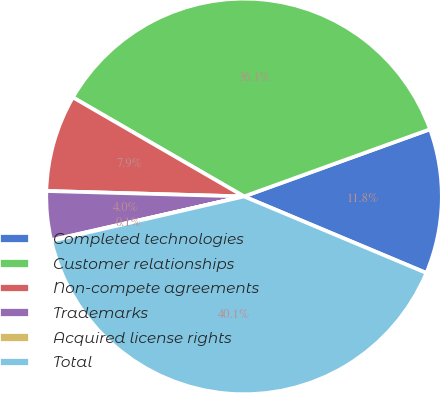Convert chart. <chart><loc_0><loc_0><loc_500><loc_500><pie_chart><fcel>Completed technologies<fcel>Customer relationships<fcel>Non-compete agreements<fcel>Trademarks<fcel>Acquired license rights<fcel>Total<nl><fcel>11.84%<fcel>36.13%<fcel>7.91%<fcel>3.99%<fcel>0.06%<fcel>40.06%<nl></chart> 